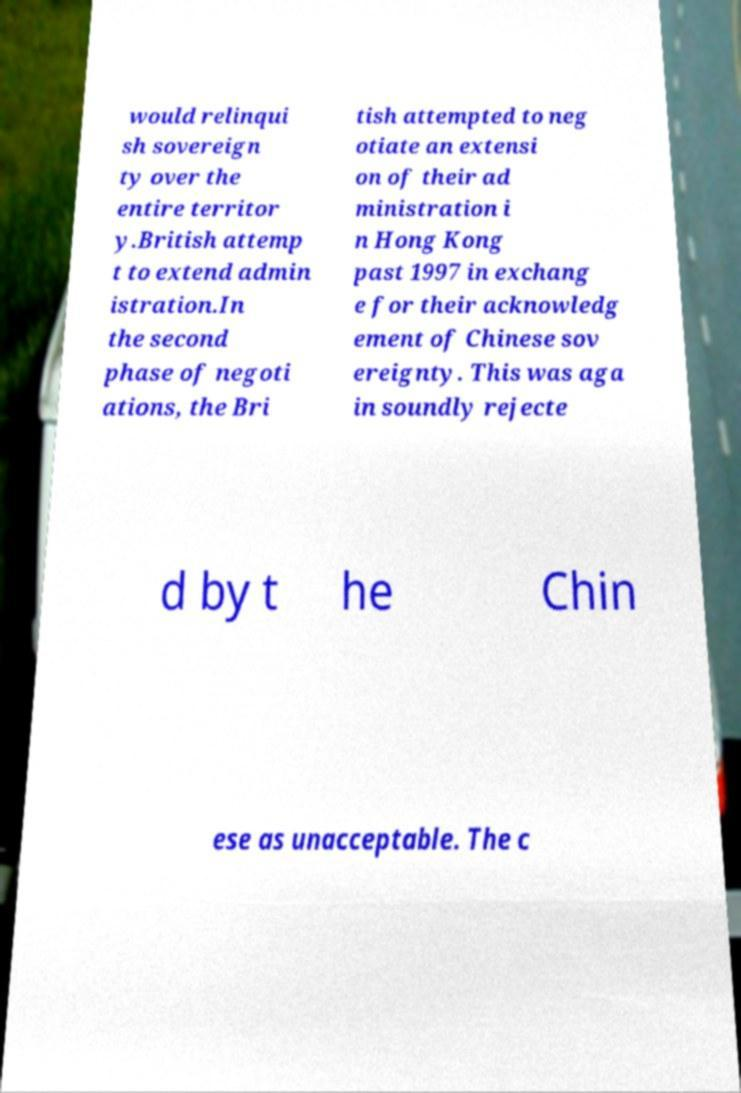Could you assist in decoding the text presented in this image and type it out clearly? would relinqui sh sovereign ty over the entire territor y.British attemp t to extend admin istration.In the second phase of negoti ations, the Bri tish attempted to neg otiate an extensi on of their ad ministration i n Hong Kong past 1997 in exchang e for their acknowledg ement of Chinese sov ereignty. This was aga in soundly rejecte d by t he Chin ese as unacceptable. The c 